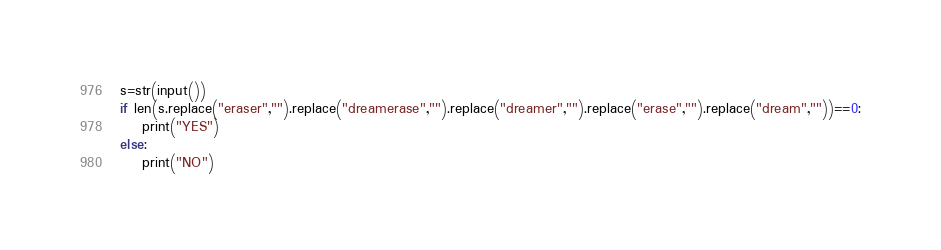<code> <loc_0><loc_0><loc_500><loc_500><_Python_>s=str(input())
if len(s.replace("eraser","").replace("dreamerase","").replace("dreamer","").replace("erase","").replace("dream",""))==0:
    print("YES")
else:
    print("NO")</code> 